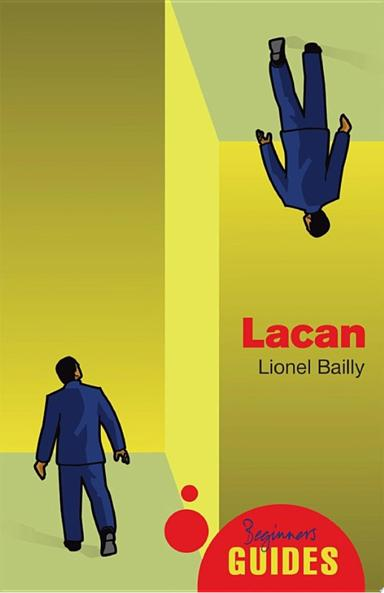What is the title and author of the guide mentioned in the image? The book displayed in the image is titled 'Lacan', authored by Lionel Bailly. It presents an introduction to Jacques Lacan's theories, tailored for beginners eager to understand his complex ideas. 